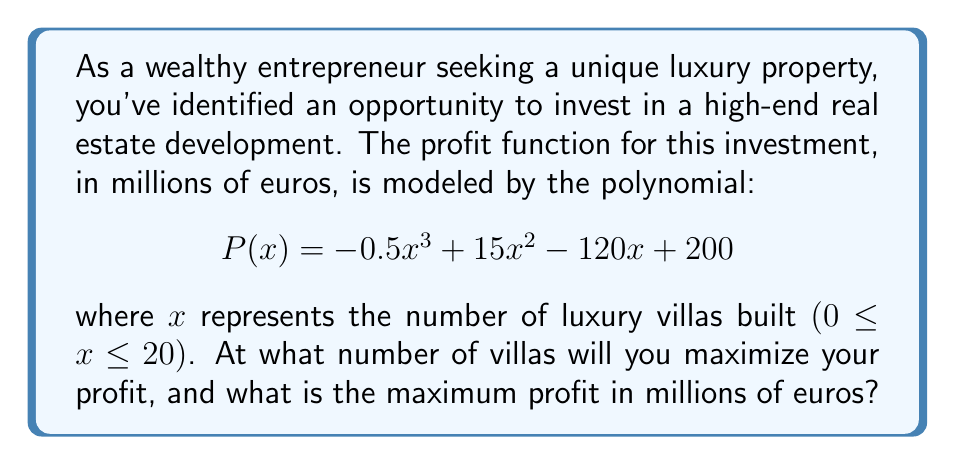Show me your answer to this math problem. To find the maximum profit point, we need to follow these steps:

1) The maximum point of a polynomial function occurs where its derivative equals zero. Let's find the derivative of $P(x)$:

   $$P'(x) = -1.5x^2 + 30x - 120$$

2) Set the derivative equal to zero and solve for x:

   $$-1.5x^2 + 30x - 120 = 0$$

3) This is a quadratic equation. We can solve it using the quadratic formula:
   
   $$x = \frac{-b \pm \sqrt{b^2 - 4ac}}{2a}$$

   Where $a = -1.5$, $b = 30$, and $c = -120$

4) Plugging in these values:

   $$x = \frac{-30 \pm \sqrt{30^2 - 4(-1.5)(-120)}}{2(-1.5)}$$
   
   $$= \frac{-30 \pm \sqrt{900 - 720}}{-3}$$
   
   $$= \frac{-30 \pm \sqrt{180}}{-3}$$
   
   $$= \frac{-30 \pm 6\sqrt{5}}{-3}$$

5) This gives us two solutions:

   $$x_1 = \frac{-30 + 6\sqrt{5}}{-3} = 10 - 2\sqrt{5} \approx 5.53$$
   
   $$x_2 = \frac{-30 - 6\sqrt{5}}{-3} = 10 + 2\sqrt{5} \approx 14.47$$

6) Since we're looking for a maximum, and the coefficient of $x^3$ in the original function is negative, the maximum occurs at the larger x-value.

7) However, since we can only build a whole number of villas, we need to round to the nearest integer. So, the number of villas that maximizes profit is 14.

8) To find the maximum profit, we plug x = 14 into the original profit function:

   $$P(14) = -0.5(14)^3 + 15(14)^2 - 120(14) + 200$$
   
   $$= -1372 + 2940 - 1680 + 200$$
   
   $$= 88$$

Therefore, the maximum profit is 88 million euros.
Answer: The profit is maximized when 14 luxury villas are built, resulting in a maximum profit of 88 million euros. 